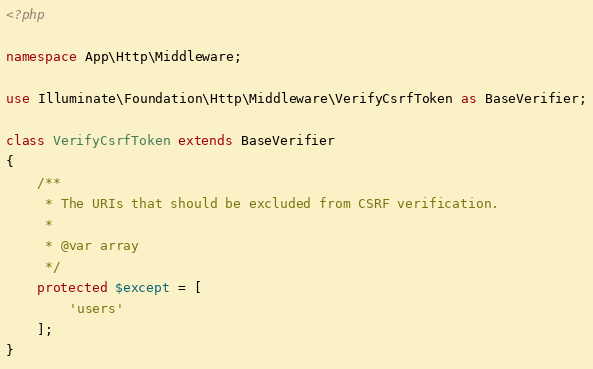Convert code to text. <code><loc_0><loc_0><loc_500><loc_500><_PHP_><?php

namespace App\Http\Middleware;

use Illuminate\Foundation\Http\Middleware\VerifyCsrfToken as BaseVerifier;

class VerifyCsrfToken extends BaseVerifier
{
    /**
     * The URIs that should be excluded from CSRF verification.
     *
     * @var array
     */
    protected $except = [
        'users'
    ];
}
</code> 